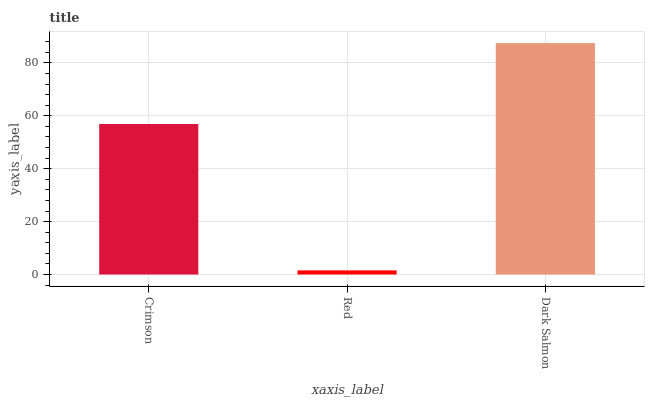Is Red the minimum?
Answer yes or no. Yes. Is Dark Salmon the maximum?
Answer yes or no. Yes. Is Dark Salmon the minimum?
Answer yes or no. No. Is Red the maximum?
Answer yes or no. No. Is Dark Salmon greater than Red?
Answer yes or no. Yes. Is Red less than Dark Salmon?
Answer yes or no. Yes. Is Red greater than Dark Salmon?
Answer yes or no. No. Is Dark Salmon less than Red?
Answer yes or no. No. Is Crimson the high median?
Answer yes or no. Yes. Is Crimson the low median?
Answer yes or no. Yes. Is Dark Salmon the high median?
Answer yes or no. No. Is Dark Salmon the low median?
Answer yes or no. No. 